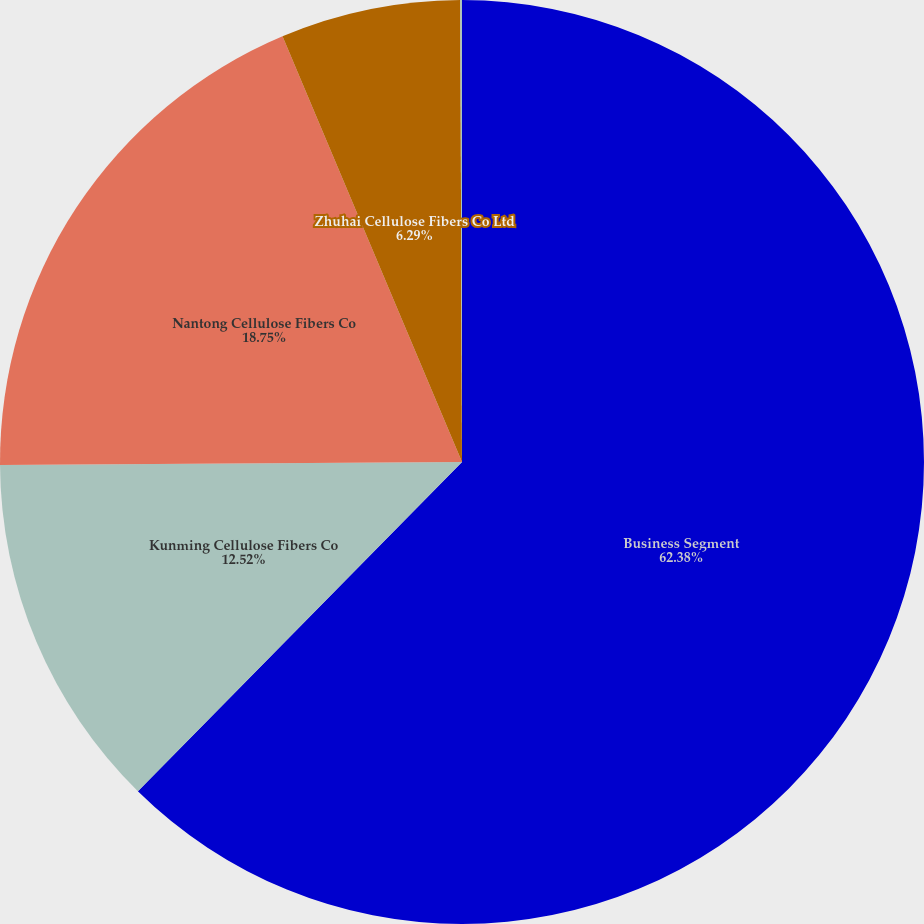Convert chart. <chart><loc_0><loc_0><loc_500><loc_500><pie_chart><fcel>Business Segment<fcel>Kunming Cellulose Fibers Co<fcel>Nantong Cellulose Fibers Co<fcel>Zhuhai Cellulose Fibers Co Ltd<fcel>InfraServ GmbH & Co Wiesbaden<nl><fcel>62.37%<fcel>12.52%<fcel>18.75%<fcel>6.29%<fcel>0.06%<nl></chart> 